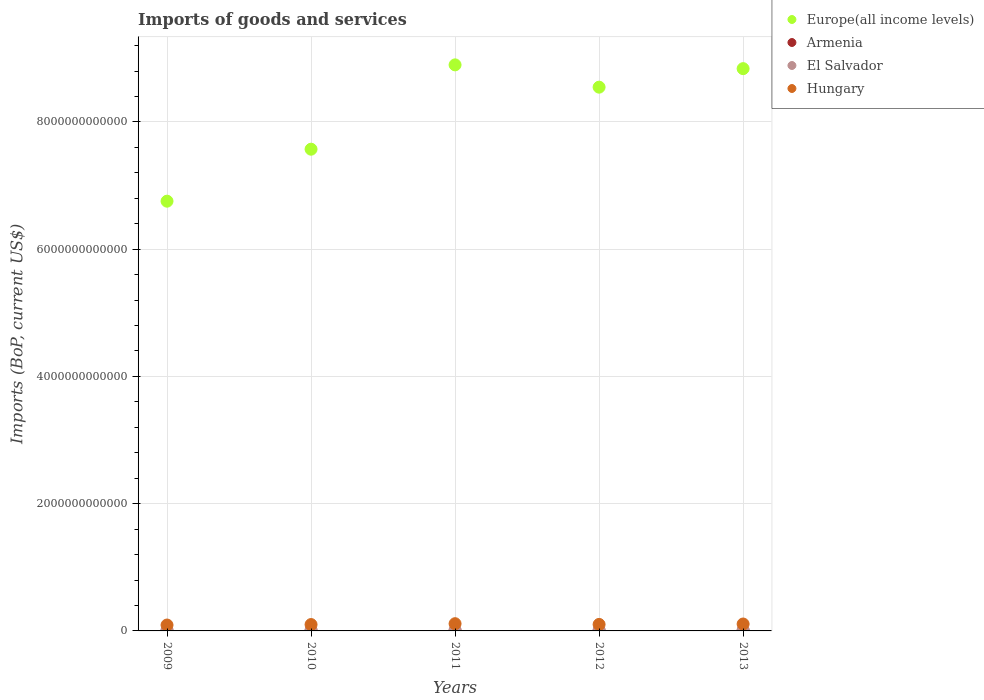Is the number of dotlines equal to the number of legend labels?
Provide a short and direct response. Yes. What is the amount spent on imports in Europe(all income levels) in 2009?
Provide a succinct answer. 6.75e+12. Across all years, what is the maximum amount spent on imports in Hungary?
Provide a succinct answer. 1.14e+11. Across all years, what is the minimum amount spent on imports in Europe(all income levels)?
Your answer should be very brief. 6.75e+12. In which year was the amount spent on imports in Europe(all income levels) minimum?
Keep it short and to the point. 2009. What is the total amount spent on imports in El Salvador in the graph?
Keep it short and to the point. 4.78e+1. What is the difference between the amount spent on imports in Europe(all income levels) in 2011 and that in 2012?
Your answer should be compact. 3.51e+11. What is the difference between the amount spent on imports in Hungary in 2013 and the amount spent on imports in Europe(all income levels) in 2012?
Your answer should be very brief. -8.44e+12. What is the average amount spent on imports in Hungary per year?
Offer a very short reply. 1.03e+11. In the year 2010, what is the difference between the amount spent on imports in Armenia and amount spent on imports in El Salvador?
Your answer should be compact. -4.06e+09. In how many years, is the amount spent on imports in El Salvador greater than 1200000000000 US$?
Your answer should be compact. 0. What is the ratio of the amount spent on imports in El Salvador in 2010 to that in 2012?
Offer a very short reply. 0.82. Is the amount spent on imports in Armenia in 2012 less than that in 2013?
Your response must be concise. Yes. What is the difference between the highest and the second highest amount spent on imports in Europe(all income levels)?
Provide a short and direct response. 5.94e+1. What is the difference between the highest and the lowest amount spent on imports in Armenia?
Offer a very short reply. 1.44e+09. In how many years, is the amount spent on imports in El Salvador greater than the average amount spent on imports in El Salvador taken over all years?
Keep it short and to the point. 3. Is the sum of the amount spent on imports in Hungary in 2010 and 2011 greater than the maximum amount spent on imports in Europe(all income levels) across all years?
Make the answer very short. No. Is it the case that in every year, the sum of the amount spent on imports in El Salvador and amount spent on imports in Europe(all income levels)  is greater than the sum of amount spent on imports in Hungary and amount spent on imports in Armenia?
Make the answer very short. Yes. Does the amount spent on imports in Hungary monotonically increase over the years?
Ensure brevity in your answer.  No. Is the amount spent on imports in El Salvador strictly greater than the amount spent on imports in Europe(all income levels) over the years?
Provide a short and direct response. No. How many years are there in the graph?
Provide a succinct answer. 5. What is the difference between two consecutive major ticks on the Y-axis?
Provide a succinct answer. 2.00e+12. Does the graph contain grids?
Ensure brevity in your answer.  Yes. What is the title of the graph?
Ensure brevity in your answer.  Imports of goods and services. Does "St. Vincent and the Grenadines" appear as one of the legend labels in the graph?
Your answer should be very brief. No. What is the label or title of the X-axis?
Provide a short and direct response. Years. What is the label or title of the Y-axis?
Your response must be concise. Imports (BoP, current US$). What is the Imports (BoP, current US$) of Europe(all income levels) in 2009?
Provide a succinct answer. 6.75e+12. What is the Imports (BoP, current US$) of Armenia in 2009?
Make the answer very short. 3.93e+09. What is the Imports (BoP, current US$) in El Salvador in 2009?
Provide a short and direct response. 7.41e+09. What is the Imports (BoP, current US$) of Hungary in 2009?
Offer a terse response. 9.26e+1. What is the Imports (BoP, current US$) of Europe(all income levels) in 2010?
Make the answer very short. 7.57e+12. What is the Imports (BoP, current US$) of Armenia in 2010?
Your response must be concise. 4.54e+09. What is the Imports (BoP, current US$) in El Salvador in 2010?
Offer a very short reply. 8.60e+09. What is the Imports (BoP, current US$) of Hungary in 2010?
Offer a very short reply. 1.00e+11. What is the Imports (BoP, current US$) in Europe(all income levels) in 2011?
Offer a very short reply. 8.90e+12. What is the Imports (BoP, current US$) in Armenia in 2011?
Make the answer very short. 4.92e+09. What is the Imports (BoP, current US$) of El Salvador in 2011?
Provide a succinct answer. 1.02e+1. What is the Imports (BoP, current US$) in Hungary in 2011?
Offer a terse response. 1.14e+11. What is the Imports (BoP, current US$) in Europe(all income levels) in 2012?
Provide a succinct answer. 8.55e+12. What is the Imports (BoP, current US$) in Armenia in 2012?
Offer a terse response. 5.13e+09. What is the Imports (BoP, current US$) in El Salvador in 2012?
Your answer should be compact. 1.05e+1. What is the Imports (BoP, current US$) of Hungary in 2012?
Your answer should be very brief. 1.02e+11. What is the Imports (BoP, current US$) of Europe(all income levels) in 2013?
Offer a very short reply. 8.84e+12. What is the Imports (BoP, current US$) of Armenia in 2013?
Make the answer very short. 5.36e+09. What is the Imports (BoP, current US$) in El Salvador in 2013?
Keep it short and to the point. 1.11e+1. What is the Imports (BoP, current US$) of Hungary in 2013?
Make the answer very short. 1.09e+11. Across all years, what is the maximum Imports (BoP, current US$) in Europe(all income levels)?
Offer a very short reply. 8.90e+12. Across all years, what is the maximum Imports (BoP, current US$) in Armenia?
Ensure brevity in your answer.  5.36e+09. Across all years, what is the maximum Imports (BoP, current US$) in El Salvador?
Keep it short and to the point. 1.11e+1. Across all years, what is the maximum Imports (BoP, current US$) of Hungary?
Make the answer very short. 1.14e+11. Across all years, what is the minimum Imports (BoP, current US$) of Europe(all income levels)?
Ensure brevity in your answer.  6.75e+12. Across all years, what is the minimum Imports (BoP, current US$) in Armenia?
Provide a succinct answer. 3.93e+09. Across all years, what is the minimum Imports (BoP, current US$) of El Salvador?
Provide a short and direct response. 7.41e+09. Across all years, what is the minimum Imports (BoP, current US$) of Hungary?
Keep it short and to the point. 9.26e+1. What is the total Imports (BoP, current US$) of Europe(all income levels) in the graph?
Your response must be concise. 4.06e+13. What is the total Imports (BoP, current US$) in Armenia in the graph?
Offer a very short reply. 2.39e+1. What is the total Imports (BoP, current US$) of El Salvador in the graph?
Provide a short and direct response. 4.78e+1. What is the total Imports (BoP, current US$) of Hungary in the graph?
Your response must be concise. 5.17e+11. What is the difference between the Imports (BoP, current US$) of Europe(all income levels) in 2009 and that in 2010?
Your answer should be compact. -8.17e+11. What is the difference between the Imports (BoP, current US$) of Armenia in 2009 and that in 2010?
Offer a terse response. -6.12e+08. What is the difference between the Imports (BoP, current US$) in El Salvador in 2009 and that in 2010?
Your answer should be compact. -1.18e+09. What is the difference between the Imports (BoP, current US$) of Hungary in 2009 and that in 2010?
Provide a succinct answer. -7.52e+09. What is the difference between the Imports (BoP, current US$) in Europe(all income levels) in 2009 and that in 2011?
Your answer should be very brief. -2.14e+12. What is the difference between the Imports (BoP, current US$) in Armenia in 2009 and that in 2011?
Make the answer very short. -9.92e+08. What is the difference between the Imports (BoP, current US$) of El Salvador in 2009 and that in 2011?
Offer a terse response. -2.79e+09. What is the difference between the Imports (BoP, current US$) of Hungary in 2009 and that in 2011?
Keep it short and to the point. -2.10e+1. What is the difference between the Imports (BoP, current US$) of Europe(all income levels) in 2009 and that in 2012?
Make the answer very short. -1.79e+12. What is the difference between the Imports (BoP, current US$) of Armenia in 2009 and that in 2012?
Make the answer very short. -1.21e+09. What is the difference between the Imports (BoP, current US$) in El Salvador in 2009 and that in 2012?
Keep it short and to the point. -3.08e+09. What is the difference between the Imports (BoP, current US$) in Hungary in 2009 and that in 2012?
Keep it short and to the point. -9.62e+09. What is the difference between the Imports (BoP, current US$) of Europe(all income levels) in 2009 and that in 2013?
Give a very brief answer. -2.08e+12. What is the difference between the Imports (BoP, current US$) of Armenia in 2009 and that in 2013?
Provide a short and direct response. -1.44e+09. What is the difference between the Imports (BoP, current US$) in El Salvador in 2009 and that in 2013?
Offer a very short reply. -3.68e+09. What is the difference between the Imports (BoP, current US$) in Hungary in 2009 and that in 2013?
Your response must be concise. -1.62e+1. What is the difference between the Imports (BoP, current US$) in Europe(all income levels) in 2010 and that in 2011?
Your response must be concise. -1.33e+12. What is the difference between the Imports (BoP, current US$) in Armenia in 2010 and that in 2011?
Give a very brief answer. -3.81e+08. What is the difference between the Imports (BoP, current US$) in El Salvador in 2010 and that in 2011?
Offer a very short reply. -1.61e+09. What is the difference between the Imports (BoP, current US$) in Hungary in 2010 and that in 2011?
Provide a succinct answer. -1.35e+1. What is the difference between the Imports (BoP, current US$) in Europe(all income levels) in 2010 and that in 2012?
Offer a very short reply. -9.75e+11. What is the difference between the Imports (BoP, current US$) of Armenia in 2010 and that in 2012?
Ensure brevity in your answer.  -5.94e+08. What is the difference between the Imports (BoP, current US$) in El Salvador in 2010 and that in 2012?
Provide a short and direct response. -1.90e+09. What is the difference between the Imports (BoP, current US$) in Hungary in 2010 and that in 2012?
Your response must be concise. -2.10e+09. What is the difference between the Imports (BoP, current US$) in Europe(all income levels) in 2010 and that in 2013?
Provide a succinct answer. -1.27e+12. What is the difference between the Imports (BoP, current US$) in Armenia in 2010 and that in 2013?
Give a very brief answer. -8.28e+08. What is the difference between the Imports (BoP, current US$) of El Salvador in 2010 and that in 2013?
Your response must be concise. -2.50e+09. What is the difference between the Imports (BoP, current US$) of Hungary in 2010 and that in 2013?
Your response must be concise. -8.65e+09. What is the difference between the Imports (BoP, current US$) in Europe(all income levels) in 2011 and that in 2012?
Make the answer very short. 3.51e+11. What is the difference between the Imports (BoP, current US$) in Armenia in 2011 and that in 2012?
Offer a very short reply. -2.14e+08. What is the difference between the Imports (BoP, current US$) of El Salvador in 2011 and that in 2012?
Provide a succinct answer. -2.95e+08. What is the difference between the Imports (BoP, current US$) in Hungary in 2011 and that in 2012?
Provide a short and direct response. 1.14e+1. What is the difference between the Imports (BoP, current US$) of Europe(all income levels) in 2011 and that in 2013?
Ensure brevity in your answer.  5.94e+1. What is the difference between the Imports (BoP, current US$) of Armenia in 2011 and that in 2013?
Give a very brief answer. -4.47e+08. What is the difference between the Imports (BoP, current US$) of El Salvador in 2011 and that in 2013?
Provide a short and direct response. -8.97e+08. What is the difference between the Imports (BoP, current US$) of Hungary in 2011 and that in 2013?
Ensure brevity in your answer.  4.83e+09. What is the difference between the Imports (BoP, current US$) in Europe(all income levels) in 2012 and that in 2013?
Give a very brief answer. -2.91e+11. What is the difference between the Imports (BoP, current US$) of Armenia in 2012 and that in 2013?
Provide a short and direct response. -2.34e+08. What is the difference between the Imports (BoP, current US$) in El Salvador in 2012 and that in 2013?
Your answer should be very brief. -6.02e+08. What is the difference between the Imports (BoP, current US$) of Hungary in 2012 and that in 2013?
Offer a very short reply. -6.54e+09. What is the difference between the Imports (BoP, current US$) in Europe(all income levels) in 2009 and the Imports (BoP, current US$) in Armenia in 2010?
Give a very brief answer. 6.75e+12. What is the difference between the Imports (BoP, current US$) in Europe(all income levels) in 2009 and the Imports (BoP, current US$) in El Salvador in 2010?
Your answer should be compact. 6.75e+12. What is the difference between the Imports (BoP, current US$) in Europe(all income levels) in 2009 and the Imports (BoP, current US$) in Hungary in 2010?
Ensure brevity in your answer.  6.65e+12. What is the difference between the Imports (BoP, current US$) of Armenia in 2009 and the Imports (BoP, current US$) of El Salvador in 2010?
Make the answer very short. -4.67e+09. What is the difference between the Imports (BoP, current US$) of Armenia in 2009 and the Imports (BoP, current US$) of Hungary in 2010?
Your response must be concise. -9.62e+1. What is the difference between the Imports (BoP, current US$) in El Salvador in 2009 and the Imports (BoP, current US$) in Hungary in 2010?
Give a very brief answer. -9.27e+1. What is the difference between the Imports (BoP, current US$) of Europe(all income levels) in 2009 and the Imports (BoP, current US$) of Armenia in 2011?
Offer a terse response. 6.75e+12. What is the difference between the Imports (BoP, current US$) in Europe(all income levels) in 2009 and the Imports (BoP, current US$) in El Salvador in 2011?
Your response must be concise. 6.74e+12. What is the difference between the Imports (BoP, current US$) in Europe(all income levels) in 2009 and the Imports (BoP, current US$) in Hungary in 2011?
Your answer should be very brief. 6.64e+12. What is the difference between the Imports (BoP, current US$) of Armenia in 2009 and the Imports (BoP, current US$) of El Salvador in 2011?
Offer a very short reply. -6.28e+09. What is the difference between the Imports (BoP, current US$) in Armenia in 2009 and the Imports (BoP, current US$) in Hungary in 2011?
Offer a terse response. -1.10e+11. What is the difference between the Imports (BoP, current US$) of El Salvador in 2009 and the Imports (BoP, current US$) of Hungary in 2011?
Ensure brevity in your answer.  -1.06e+11. What is the difference between the Imports (BoP, current US$) of Europe(all income levels) in 2009 and the Imports (BoP, current US$) of Armenia in 2012?
Give a very brief answer. 6.75e+12. What is the difference between the Imports (BoP, current US$) of Europe(all income levels) in 2009 and the Imports (BoP, current US$) of El Salvador in 2012?
Your answer should be compact. 6.74e+12. What is the difference between the Imports (BoP, current US$) in Europe(all income levels) in 2009 and the Imports (BoP, current US$) in Hungary in 2012?
Give a very brief answer. 6.65e+12. What is the difference between the Imports (BoP, current US$) of Armenia in 2009 and the Imports (BoP, current US$) of El Salvador in 2012?
Provide a short and direct response. -6.57e+09. What is the difference between the Imports (BoP, current US$) in Armenia in 2009 and the Imports (BoP, current US$) in Hungary in 2012?
Make the answer very short. -9.83e+1. What is the difference between the Imports (BoP, current US$) in El Salvador in 2009 and the Imports (BoP, current US$) in Hungary in 2012?
Your response must be concise. -9.48e+1. What is the difference between the Imports (BoP, current US$) of Europe(all income levels) in 2009 and the Imports (BoP, current US$) of Armenia in 2013?
Offer a very short reply. 6.75e+12. What is the difference between the Imports (BoP, current US$) in Europe(all income levels) in 2009 and the Imports (BoP, current US$) in El Salvador in 2013?
Give a very brief answer. 6.74e+12. What is the difference between the Imports (BoP, current US$) of Europe(all income levels) in 2009 and the Imports (BoP, current US$) of Hungary in 2013?
Provide a short and direct response. 6.65e+12. What is the difference between the Imports (BoP, current US$) in Armenia in 2009 and the Imports (BoP, current US$) in El Salvador in 2013?
Make the answer very short. -7.17e+09. What is the difference between the Imports (BoP, current US$) of Armenia in 2009 and the Imports (BoP, current US$) of Hungary in 2013?
Provide a succinct answer. -1.05e+11. What is the difference between the Imports (BoP, current US$) of El Salvador in 2009 and the Imports (BoP, current US$) of Hungary in 2013?
Make the answer very short. -1.01e+11. What is the difference between the Imports (BoP, current US$) of Europe(all income levels) in 2010 and the Imports (BoP, current US$) of Armenia in 2011?
Provide a short and direct response. 7.57e+12. What is the difference between the Imports (BoP, current US$) of Europe(all income levels) in 2010 and the Imports (BoP, current US$) of El Salvador in 2011?
Make the answer very short. 7.56e+12. What is the difference between the Imports (BoP, current US$) of Europe(all income levels) in 2010 and the Imports (BoP, current US$) of Hungary in 2011?
Provide a succinct answer. 7.46e+12. What is the difference between the Imports (BoP, current US$) in Armenia in 2010 and the Imports (BoP, current US$) in El Salvador in 2011?
Offer a terse response. -5.66e+09. What is the difference between the Imports (BoP, current US$) in Armenia in 2010 and the Imports (BoP, current US$) in Hungary in 2011?
Offer a very short reply. -1.09e+11. What is the difference between the Imports (BoP, current US$) in El Salvador in 2010 and the Imports (BoP, current US$) in Hungary in 2011?
Keep it short and to the point. -1.05e+11. What is the difference between the Imports (BoP, current US$) of Europe(all income levels) in 2010 and the Imports (BoP, current US$) of Armenia in 2012?
Your response must be concise. 7.57e+12. What is the difference between the Imports (BoP, current US$) of Europe(all income levels) in 2010 and the Imports (BoP, current US$) of El Salvador in 2012?
Provide a short and direct response. 7.56e+12. What is the difference between the Imports (BoP, current US$) in Europe(all income levels) in 2010 and the Imports (BoP, current US$) in Hungary in 2012?
Keep it short and to the point. 7.47e+12. What is the difference between the Imports (BoP, current US$) of Armenia in 2010 and the Imports (BoP, current US$) of El Salvador in 2012?
Keep it short and to the point. -5.96e+09. What is the difference between the Imports (BoP, current US$) of Armenia in 2010 and the Imports (BoP, current US$) of Hungary in 2012?
Offer a very short reply. -9.77e+1. What is the difference between the Imports (BoP, current US$) of El Salvador in 2010 and the Imports (BoP, current US$) of Hungary in 2012?
Your answer should be very brief. -9.36e+1. What is the difference between the Imports (BoP, current US$) of Europe(all income levels) in 2010 and the Imports (BoP, current US$) of Armenia in 2013?
Provide a succinct answer. 7.57e+12. What is the difference between the Imports (BoP, current US$) of Europe(all income levels) in 2010 and the Imports (BoP, current US$) of El Salvador in 2013?
Your response must be concise. 7.56e+12. What is the difference between the Imports (BoP, current US$) of Europe(all income levels) in 2010 and the Imports (BoP, current US$) of Hungary in 2013?
Your answer should be compact. 7.46e+12. What is the difference between the Imports (BoP, current US$) of Armenia in 2010 and the Imports (BoP, current US$) of El Salvador in 2013?
Offer a very short reply. -6.56e+09. What is the difference between the Imports (BoP, current US$) of Armenia in 2010 and the Imports (BoP, current US$) of Hungary in 2013?
Ensure brevity in your answer.  -1.04e+11. What is the difference between the Imports (BoP, current US$) in El Salvador in 2010 and the Imports (BoP, current US$) in Hungary in 2013?
Your answer should be compact. -1.00e+11. What is the difference between the Imports (BoP, current US$) in Europe(all income levels) in 2011 and the Imports (BoP, current US$) in Armenia in 2012?
Keep it short and to the point. 8.89e+12. What is the difference between the Imports (BoP, current US$) of Europe(all income levels) in 2011 and the Imports (BoP, current US$) of El Salvador in 2012?
Your answer should be very brief. 8.89e+12. What is the difference between the Imports (BoP, current US$) of Europe(all income levels) in 2011 and the Imports (BoP, current US$) of Hungary in 2012?
Offer a very short reply. 8.79e+12. What is the difference between the Imports (BoP, current US$) in Armenia in 2011 and the Imports (BoP, current US$) in El Salvador in 2012?
Your answer should be very brief. -5.58e+09. What is the difference between the Imports (BoP, current US$) of Armenia in 2011 and the Imports (BoP, current US$) of Hungary in 2012?
Provide a succinct answer. -9.73e+1. What is the difference between the Imports (BoP, current US$) in El Salvador in 2011 and the Imports (BoP, current US$) in Hungary in 2012?
Ensure brevity in your answer.  -9.20e+1. What is the difference between the Imports (BoP, current US$) in Europe(all income levels) in 2011 and the Imports (BoP, current US$) in Armenia in 2013?
Your response must be concise. 8.89e+12. What is the difference between the Imports (BoP, current US$) in Europe(all income levels) in 2011 and the Imports (BoP, current US$) in El Salvador in 2013?
Ensure brevity in your answer.  8.89e+12. What is the difference between the Imports (BoP, current US$) in Europe(all income levels) in 2011 and the Imports (BoP, current US$) in Hungary in 2013?
Your answer should be very brief. 8.79e+12. What is the difference between the Imports (BoP, current US$) in Armenia in 2011 and the Imports (BoP, current US$) in El Salvador in 2013?
Keep it short and to the point. -6.18e+09. What is the difference between the Imports (BoP, current US$) in Armenia in 2011 and the Imports (BoP, current US$) in Hungary in 2013?
Keep it short and to the point. -1.04e+11. What is the difference between the Imports (BoP, current US$) in El Salvador in 2011 and the Imports (BoP, current US$) in Hungary in 2013?
Make the answer very short. -9.85e+1. What is the difference between the Imports (BoP, current US$) in Europe(all income levels) in 2012 and the Imports (BoP, current US$) in Armenia in 2013?
Your answer should be compact. 8.54e+12. What is the difference between the Imports (BoP, current US$) of Europe(all income levels) in 2012 and the Imports (BoP, current US$) of El Salvador in 2013?
Your answer should be very brief. 8.54e+12. What is the difference between the Imports (BoP, current US$) of Europe(all income levels) in 2012 and the Imports (BoP, current US$) of Hungary in 2013?
Provide a succinct answer. 8.44e+12. What is the difference between the Imports (BoP, current US$) in Armenia in 2012 and the Imports (BoP, current US$) in El Salvador in 2013?
Give a very brief answer. -5.97e+09. What is the difference between the Imports (BoP, current US$) in Armenia in 2012 and the Imports (BoP, current US$) in Hungary in 2013?
Offer a very short reply. -1.04e+11. What is the difference between the Imports (BoP, current US$) in El Salvador in 2012 and the Imports (BoP, current US$) in Hungary in 2013?
Give a very brief answer. -9.83e+1. What is the average Imports (BoP, current US$) of Europe(all income levels) per year?
Make the answer very short. 8.12e+12. What is the average Imports (BoP, current US$) in Armenia per year?
Offer a terse response. 4.78e+09. What is the average Imports (BoP, current US$) in El Salvador per year?
Ensure brevity in your answer.  9.56e+09. What is the average Imports (BoP, current US$) in Hungary per year?
Provide a succinct answer. 1.03e+11. In the year 2009, what is the difference between the Imports (BoP, current US$) in Europe(all income levels) and Imports (BoP, current US$) in Armenia?
Provide a short and direct response. 6.75e+12. In the year 2009, what is the difference between the Imports (BoP, current US$) in Europe(all income levels) and Imports (BoP, current US$) in El Salvador?
Keep it short and to the point. 6.75e+12. In the year 2009, what is the difference between the Imports (BoP, current US$) in Europe(all income levels) and Imports (BoP, current US$) in Hungary?
Your answer should be very brief. 6.66e+12. In the year 2009, what is the difference between the Imports (BoP, current US$) of Armenia and Imports (BoP, current US$) of El Salvador?
Provide a succinct answer. -3.49e+09. In the year 2009, what is the difference between the Imports (BoP, current US$) in Armenia and Imports (BoP, current US$) in Hungary?
Offer a terse response. -8.87e+1. In the year 2009, what is the difference between the Imports (BoP, current US$) of El Salvador and Imports (BoP, current US$) of Hungary?
Your response must be concise. -8.52e+1. In the year 2010, what is the difference between the Imports (BoP, current US$) of Europe(all income levels) and Imports (BoP, current US$) of Armenia?
Provide a short and direct response. 7.57e+12. In the year 2010, what is the difference between the Imports (BoP, current US$) of Europe(all income levels) and Imports (BoP, current US$) of El Salvador?
Offer a terse response. 7.56e+12. In the year 2010, what is the difference between the Imports (BoP, current US$) in Europe(all income levels) and Imports (BoP, current US$) in Hungary?
Your answer should be compact. 7.47e+12. In the year 2010, what is the difference between the Imports (BoP, current US$) of Armenia and Imports (BoP, current US$) of El Salvador?
Keep it short and to the point. -4.06e+09. In the year 2010, what is the difference between the Imports (BoP, current US$) in Armenia and Imports (BoP, current US$) in Hungary?
Your answer should be compact. -9.56e+1. In the year 2010, what is the difference between the Imports (BoP, current US$) in El Salvador and Imports (BoP, current US$) in Hungary?
Your answer should be compact. -9.15e+1. In the year 2011, what is the difference between the Imports (BoP, current US$) in Europe(all income levels) and Imports (BoP, current US$) in Armenia?
Provide a succinct answer. 8.89e+12. In the year 2011, what is the difference between the Imports (BoP, current US$) in Europe(all income levels) and Imports (BoP, current US$) in El Salvador?
Offer a terse response. 8.89e+12. In the year 2011, what is the difference between the Imports (BoP, current US$) of Europe(all income levels) and Imports (BoP, current US$) of Hungary?
Ensure brevity in your answer.  8.78e+12. In the year 2011, what is the difference between the Imports (BoP, current US$) in Armenia and Imports (BoP, current US$) in El Salvador?
Keep it short and to the point. -5.28e+09. In the year 2011, what is the difference between the Imports (BoP, current US$) of Armenia and Imports (BoP, current US$) of Hungary?
Make the answer very short. -1.09e+11. In the year 2011, what is the difference between the Imports (BoP, current US$) in El Salvador and Imports (BoP, current US$) in Hungary?
Your answer should be very brief. -1.03e+11. In the year 2012, what is the difference between the Imports (BoP, current US$) in Europe(all income levels) and Imports (BoP, current US$) in Armenia?
Offer a terse response. 8.54e+12. In the year 2012, what is the difference between the Imports (BoP, current US$) of Europe(all income levels) and Imports (BoP, current US$) of El Salvador?
Provide a short and direct response. 8.54e+12. In the year 2012, what is the difference between the Imports (BoP, current US$) of Europe(all income levels) and Imports (BoP, current US$) of Hungary?
Make the answer very short. 8.44e+12. In the year 2012, what is the difference between the Imports (BoP, current US$) in Armenia and Imports (BoP, current US$) in El Salvador?
Provide a succinct answer. -5.36e+09. In the year 2012, what is the difference between the Imports (BoP, current US$) of Armenia and Imports (BoP, current US$) of Hungary?
Provide a succinct answer. -9.71e+1. In the year 2012, what is the difference between the Imports (BoP, current US$) in El Salvador and Imports (BoP, current US$) in Hungary?
Provide a succinct answer. -9.17e+1. In the year 2013, what is the difference between the Imports (BoP, current US$) of Europe(all income levels) and Imports (BoP, current US$) of Armenia?
Make the answer very short. 8.83e+12. In the year 2013, what is the difference between the Imports (BoP, current US$) in Europe(all income levels) and Imports (BoP, current US$) in El Salvador?
Ensure brevity in your answer.  8.83e+12. In the year 2013, what is the difference between the Imports (BoP, current US$) of Europe(all income levels) and Imports (BoP, current US$) of Hungary?
Keep it short and to the point. 8.73e+12. In the year 2013, what is the difference between the Imports (BoP, current US$) of Armenia and Imports (BoP, current US$) of El Salvador?
Provide a short and direct response. -5.73e+09. In the year 2013, what is the difference between the Imports (BoP, current US$) in Armenia and Imports (BoP, current US$) in Hungary?
Your answer should be compact. -1.03e+11. In the year 2013, what is the difference between the Imports (BoP, current US$) of El Salvador and Imports (BoP, current US$) of Hungary?
Make the answer very short. -9.77e+1. What is the ratio of the Imports (BoP, current US$) in Europe(all income levels) in 2009 to that in 2010?
Offer a terse response. 0.89. What is the ratio of the Imports (BoP, current US$) in Armenia in 2009 to that in 2010?
Your answer should be very brief. 0.87. What is the ratio of the Imports (BoP, current US$) in El Salvador in 2009 to that in 2010?
Offer a very short reply. 0.86. What is the ratio of the Imports (BoP, current US$) in Hungary in 2009 to that in 2010?
Provide a short and direct response. 0.92. What is the ratio of the Imports (BoP, current US$) of Europe(all income levels) in 2009 to that in 2011?
Ensure brevity in your answer.  0.76. What is the ratio of the Imports (BoP, current US$) in Armenia in 2009 to that in 2011?
Your answer should be very brief. 0.8. What is the ratio of the Imports (BoP, current US$) of El Salvador in 2009 to that in 2011?
Ensure brevity in your answer.  0.73. What is the ratio of the Imports (BoP, current US$) of Hungary in 2009 to that in 2011?
Your response must be concise. 0.82. What is the ratio of the Imports (BoP, current US$) of Europe(all income levels) in 2009 to that in 2012?
Give a very brief answer. 0.79. What is the ratio of the Imports (BoP, current US$) in Armenia in 2009 to that in 2012?
Offer a terse response. 0.77. What is the ratio of the Imports (BoP, current US$) in El Salvador in 2009 to that in 2012?
Your answer should be compact. 0.71. What is the ratio of the Imports (BoP, current US$) of Hungary in 2009 to that in 2012?
Ensure brevity in your answer.  0.91. What is the ratio of the Imports (BoP, current US$) in Europe(all income levels) in 2009 to that in 2013?
Your answer should be very brief. 0.76. What is the ratio of the Imports (BoP, current US$) of Armenia in 2009 to that in 2013?
Ensure brevity in your answer.  0.73. What is the ratio of the Imports (BoP, current US$) in El Salvador in 2009 to that in 2013?
Give a very brief answer. 0.67. What is the ratio of the Imports (BoP, current US$) in Hungary in 2009 to that in 2013?
Provide a succinct answer. 0.85. What is the ratio of the Imports (BoP, current US$) of Europe(all income levels) in 2010 to that in 2011?
Ensure brevity in your answer.  0.85. What is the ratio of the Imports (BoP, current US$) in Armenia in 2010 to that in 2011?
Offer a terse response. 0.92. What is the ratio of the Imports (BoP, current US$) in El Salvador in 2010 to that in 2011?
Ensure brevity in your answer.  0.84. What is the ratio of the Imports (BoP, current US$) of Hungary in 2010 to that in 2011?
Your response must be concise. 0.88. What is the ratio of the Imports (BoP, current US$) in Europe(all income levels) in 2010 to that in 2012?
Your answer should be compact. 0.89. What is the ratio of the Imports (BoP, current US$) of Armenia in 2010 to that in 2012?
Provide a succinct answer. 0.88. What is the ratio of the Imports (BoP, current US$) in El Salvador in 2010 to that in 2012?
Offer a terse response. 0.82. What is the ratio of the Imports (BoP, current US$) in Hungary in 2010 to that in 2012?
Offer a terse response. 0.98. What is the ratio of the Imports (BoP, current US$) in Europe(all income levels) in 2010 to that in 2013?
Make the answer very short. 0.86. What is the ratio of the Imports (BoP, current US$) of Armenia in 2010 to that in 2013?
Provide a succinct answer. 0.85. What is the ratio of the Imports (BoP, current US$) of El Salvador in 2010 to that in 2013?
Provide a succinct answer. 0.77. What is the ratio of the Imports (BoP, current US$) of Hungary in 2010 to that in 2013?
Provide a short and direct response. 0.92. What is the ratio of the Imports (BoP, current US$) in Europe(all income levels) in 2011 to that in 2012?
Provide a short and direct response. 1.04. What is the ratio of the Imports (BoP, current US$) of Armenia in 2011 to that in 2012?
Your response must be concise. 0.96. What is the ratio of the Imports (BoP, current US$) in El Salvador in 2011 to that in 2012?
Your answer should be compact. 0.97. What is the ratio of the Imports (BoP, current US$) of Hungary in 2011 to that in 2012?
Give a very brief answer. 1.11. What is the ratio of the Imports (BoP, current US$) in Europe(all income levels) in 2011 to that in 2013?
Provide a succinct answer. 1.01. What is the ratio of the Imports (BoP, current US$) in Armenia in 2011 to that in 2013?
Your answer should be compact. 0.92. What is the ratio of the Imports (BoP, current US$) of El Salvador in 2011 to that in 2013?
Provide a short and direct response. 0.92. What is the ratio of the Imports (BoP, current US$) of Hungary in 2011 to that in 2013?
Offer a terse response. 1.04. What is the ratio of the Imports (BoP, current US$) in Europe(all income levels) in 2012 to that in 2013?
Provide a short and direct response. 0.97. What is the ratio of the Imports (BoP, current US$) in Armenia in 2012 to that in 2013?
Your response must be concise. 0.96. What is the ratio of the Imports (BoP, current US$) of El Salvador in 2012 to that in 2013?
Provide a succinct answer. 0.95. What is the ratio of the Imports (BoP, current US$) in Hungary in 2012 to that in 2013?
Offer a very short reply. 0.94. What is the difference between the highest and the second highest Imports (BoP, current US$) of Europe(all income levels)?
Offer a terse response. 5.94e+1. What is the difference between the highest and the second highest Imports (BoP, current US$) in Armenia?
Your answer should be very brief. 2.34e+08. What is the difference between the highest and the second highest Imports (BoP, current US$) of El Salvador?
Provide a succinct answer. 6.02e+08. What is the difference between the highest and the second highest Imports (BoP, current US$) of Hungary?
Your response must be concise. 4.83e+09. What is the difference between the highest and the lowest Imports (BoP, current US$) in Europe(all income levels)?
Provide a succinct answer. 2.14e+12. What is the difference between the highest and the lowest Imports (BoP, current US$) of Armenia?
Keep it short and to the point. 1.44e+09. What is the difference between the highest and the lowest Imports (BoP, current US$) in El Salvador?
Your answer should be very brief. 3.68e+09. What is the difference between the highest and the lowest Imports (BoP, current US$) of Hungary?
Offer a terse response. 2.10e+1. 